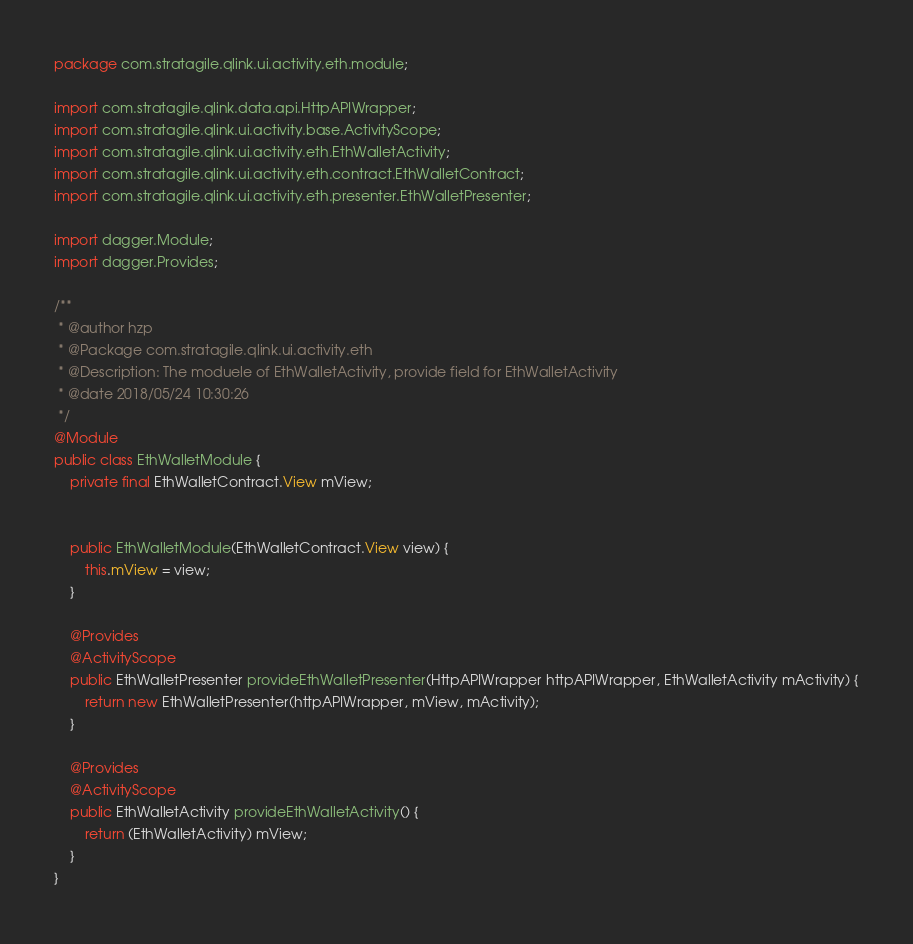Convert code to text. <code><loc_0><loc_0><loc_500><loc_500><_Java_>package com.stratagile.qlink.ui.activity.eth.module;

import com.stratagile.qlink.data.api.HttpAPIWrapper;
import com.stratagile.qlink.ui.activity.base.ActivityScope;
import com.stratagile.qlink.ui.activity.eth.EthWalletActivity;
import com.stratagile.qlink.ui.activity.eth.contract.EthWalletContract;
import com.stratagile.qlink.ui.activity.eth.presenter.EthWalletPresenter;

import dagger.Module;
import dagger.Provides;

/**
 * @author hzp
 * @Package com.stratagile.qlink.ui.activity.eth
 * @Description: The moduele of EthWalletActivity, provide field for EthWalletActivity
 * @date 2018/05/24 10:30:26
 */
@Module
public class EthWalletModule {
    private final EthWalletContract.View mView;


    public EthWalletModule(EthWalletContract.View view) {
        this.mView = view;
    }

    @Provides
    @ActivityScope
    public EthWalletPresenter provideEthWalletPresenter(HttpAPIWrapper httpAPIWrapper, EthWalletActivity mActivity) {
        return new EthWalletPresenter(httpAPIWrapper, mView, mActivity);
    }

    @Provides
    @ActivityScope
    public EthWalletActivity provideEthWalletActivity() {
        return (EthWalletActivity) mView;
    }
}</code> 